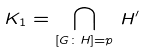Convert formula to latex. <formula><loc_0><loc_0><loc_500><loc_500>K _ { 1 } = \bigcap _ { [ G \colon H ] = p } \, H ^ { \prime }</formula> 